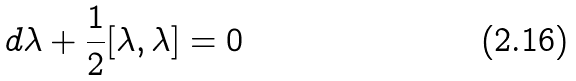Convert formula to latex. <formula><loc_0><loc_0><loc_500><loc_500>d \lambda + \frac { 1 } { 2 } [ \lambda , \lambda ] = 0</formula> 